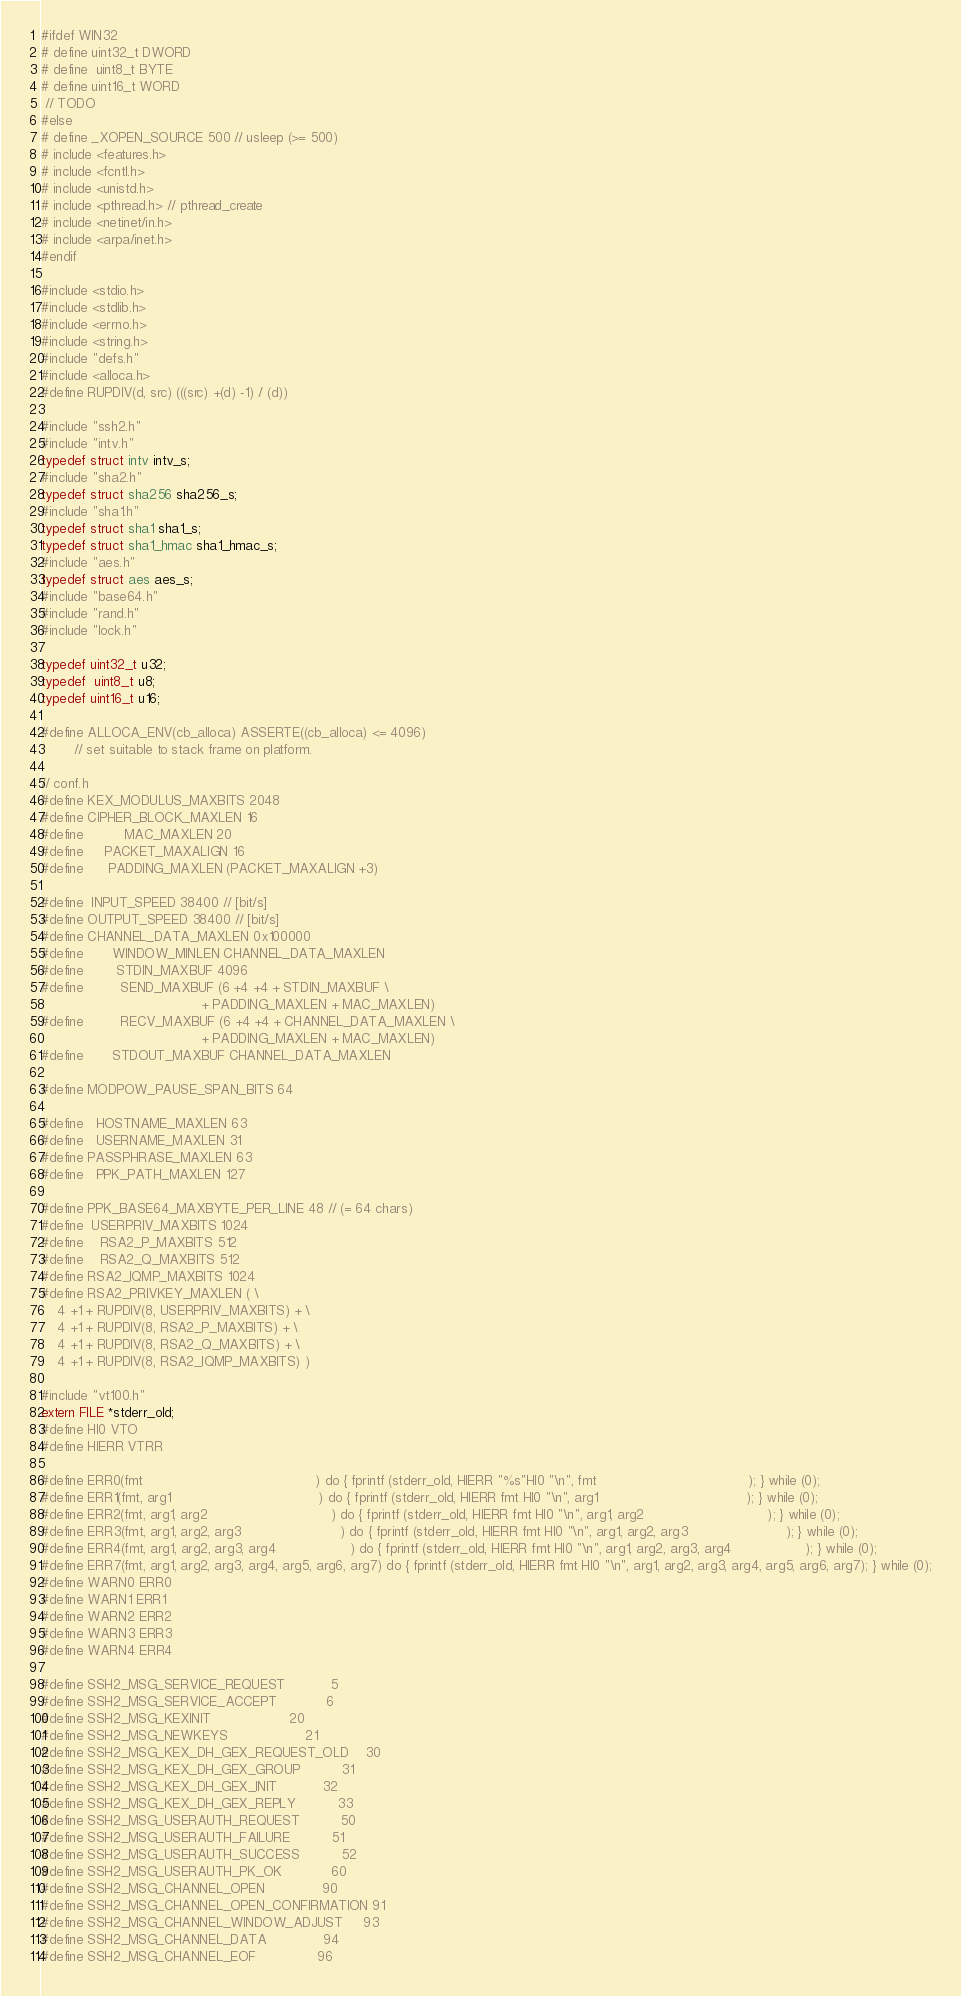Convert code to text. <code><loc_0><loc_0><loc_500><loc_500><_C_>#ifdef WIN32
# define uint32_t DWORD
# define  uint8_t BYTE
# define uint16_t WORD
 // TODO
#else
# define _XOPEN_SOURCE 500 // usleep (>= 500)
# include <features.h>
# include <fcntl.h>
# include <unistd.h>
# include <pthread.h> // pthread_create
# include <netinet/in.h>
# include <arpa/inet.h>
#endif

#include <stdio.h>
#include <stdlib.h>
#include <errno.h>
#include <string.h>
#include "defs.h"
#include <alloca.h>
#define RUPDIV(d, src) (((src) +(d) -1) / (d))

#include "ssh2.h"
#include "intv.h"
typedef struct intv intv_s;
#include "sha2.h"
typedef struct sha256 sha256_s;
#include "sha1.h"
typedef struct sha1 sha1_s;
typedef struct sha1_hmac sha1_hmac_s;
#include "aes.h"
typedef struct aes aes_s;
#include "base64.h"
#include "rand.h"
#include "lock.h"

typedef uint32_t u32;
typedef  uint8_t u8;
typedef uint16_t u16;

#define ALLOCA_ENV(cb_alloca) ASSERTE((cb_alloca) <= 4096)
        // set suitable to stack frame on platform.

// conf.h
#define KEX_MODULUS_MAXBITS 2048
#define CIPHER_BLOCK_MAXLEN 16
#define          MAC_MAXLEN 20
#define     PACKET_MAXALIGN 16
#define      PADDING_MAXLEN (PACKET_MAXALIGN +3)

#define  INPUT_SPEED 38400 // [bit/s]
#define OUTPUT_SPEED 38400 // [bit/s]
#define CHANNEL_DATA_MAXLEN 0x100000
#define       WINDOW_MINLEN CHANNEL_DATA_MAXLEN
#define        STDIN_MAXBUF 4096
#define         SEND_MAXBUF (6 +4 +4 + STDIN_MAXBUF \
		                               + PADDING_MAXLEN + MAC_MAXLEN)
#define         RECV_MAXBUF (6 +4 +4 + CHANNEL_DATA_MAXLEN \
		                               + PADDING_MAXLEN + MAC_MAXLEN)
#define       STDOUT_MAXBUF CHANNEL_DATA_MAXLEN

#define MODPOW_PAUSE_SPAN_BITS 64

#define   HOSTNAME_MAXLEN 63
#define   USERNAME_MAXLEN 31
#define PASSPHRASE_MAXLEN 63
#define   PPK_PATH_MAXLEN 127

#define PPK_BASE64_MAXBYTE_PER_LINE 48 // (= 64 chars)
#define  USERPRIV_MAXBITS 1024
#define    RSA2_P_MAXBITS 512
#define    RSA2_Q_MAXBITS 512
#define RSA2_IQMP_MAXBITS 1024
#define RSA2_PRIVKEY_MAXLEN ( \
	4 +1 + RUPDIV(8, USERPRIV_MAXBITS) + \
	4 +1 + RUPDIV(8, RSA2_P_MAXBITS) + \
	4 +1 + RUPDIV(8, RSA2_Q_MAXBITS) + \
	4 +1 + RUPDIV(8, RSA2_IQMP_MAXBITS) )

#include "vt100.h"
extern FILE *stderr_old;
#define HI0 VTO
#define HIERR VTRR

#define ERR0(fmt                                          ) do { fprintf (stderr_old, HIERR "%s"HI0 "\n", fmt                                     ); } while (0);
#define ERR1(fmt, arg1                                    ) do { fprintf (stderr_old, HIERR fmt HI0 "\n", arg1                                    ); } while (0);
#define ERR2(fmt, arg1, arg2                              ) do { fprintf (stderr_old, HIERR fmt HI0 "\n", arg1, arg2                              ); } while (0);
#define ERR3(fmt, arg1, arg2, arg3                        ) do { fprintf (stderr_old, HIERR fmt HI0 "\n", arg1, arg2, arg3                        ); } while (0);
#define ERR4(fmt, arg1, arg2, arg3, arg4                  ) do { fprintf (stderr_old, HIERR fmt HI0 "\n", arg1, arg2, arg3, arg4                  ); } while (0);
#define ERR7(fmt, arg1, arg2, arg3, arg4, arg5, arg6, arg7) do { fprintf (stderr_old, HIERR fmt HI0 "\n", arg1, arg2, arg3, arg4, arg5, arg6, arg7); } while (0);
#define WARN0 ERR0
#define WARN1 ERR1
#define WARN2 ERR2
#define WARN3 ERR3
#define WARN4 ERR4

#define SSH2_MSG_SERVICE_REQUEST           5
#define SSH2_MSG_SERVICE_ACCEPT            6
#define SSH2_MSG_KEXINIT                   20
#define SSH2_MSG_NEWKEYS                   21
#define SSH2_MSG_KEX_DH_GEX_REQUEST_OLD    30
#define SSH2_MSG_KEX_DH_GEX_GROUP          31
#define SSH2_MSG_KEX_DH_GEX_INIT           32
#define SSH2_MSG_KEX_DH_GEX_REPLY          33
#define SSH2_MSG_USERAUTH_REQUEST          50
#define SSH2_MSG_USERAUTH_FAILURE          51
#define SSH2_MSG_USERAUTH_SUCCESS          52
#define SSH2_MSG_USERAUTH_PK_OK            60
#define SSH2_MSG_CHANNEL_OPEN              90
#define SSH2_MSG_CHANNEL_OPEN_CONFIRMATION 91
#define SSH2_MSG_CHANNEL_WINDOW_ADJUST     93
#define SSH2_MSG_CHANNEL_DATA              94
#define SSH2_MSG_CHANNEL_EOF               96</code> 